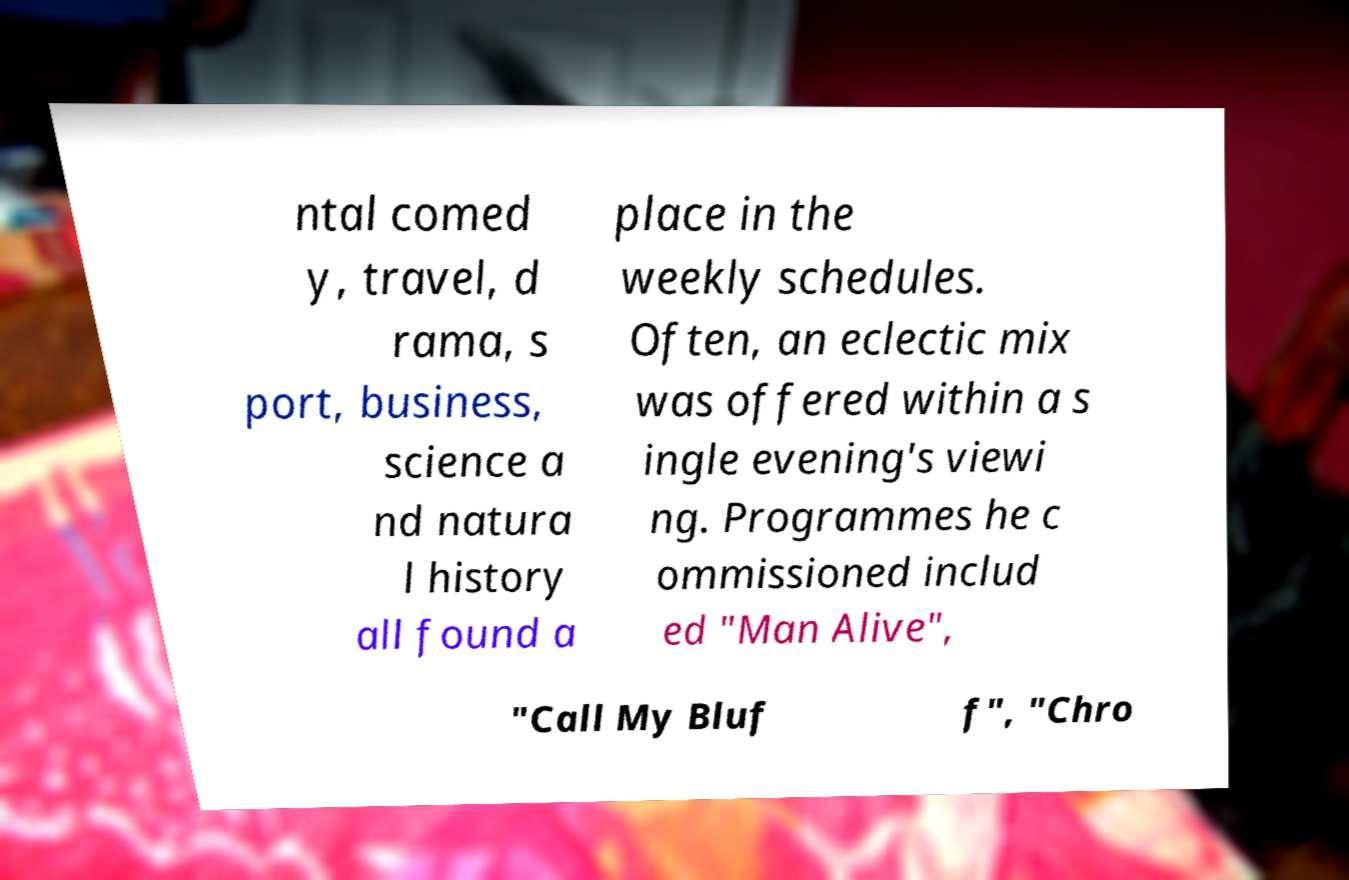Can you accurately transcribe the text from the provided image for me? ntal comed y, travel, d rama, s port, business, science a nd natura l history all found a place in the weekly schedules. Often, an eclectic mix was offered within a s ingle evening's viewi ng. Programmes he c ommissioned includ ed "Man Alive", "Call My Bluf f", "Chro 